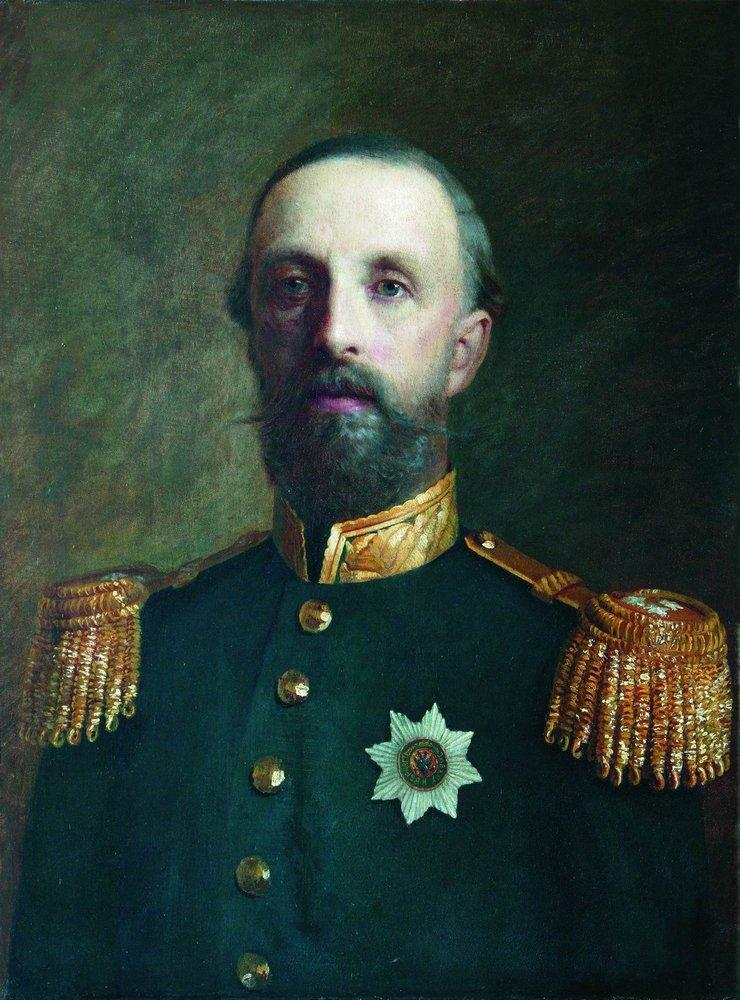Let's imagine he could speak. What would he say about his life? If the man in the portrait could speak, he might say: 'I have witnessed the best and worst of humanity. I have led men into battles where we fought for our homeland, our families, and our freedom. Every medal and insignia on my uniform tells a story of sacrifice, courage, and duty. My beard may be graying, and my strength may not be what it once was, but my spirit remains unbroken. I have served with honor, and though the times were often dark, I hold onto the belief that our sacrifices were not in vain. The weight of command is a heavy one, but it is a burden I have borne with pride, knowing that my actions have shaped the future of my nation.' 